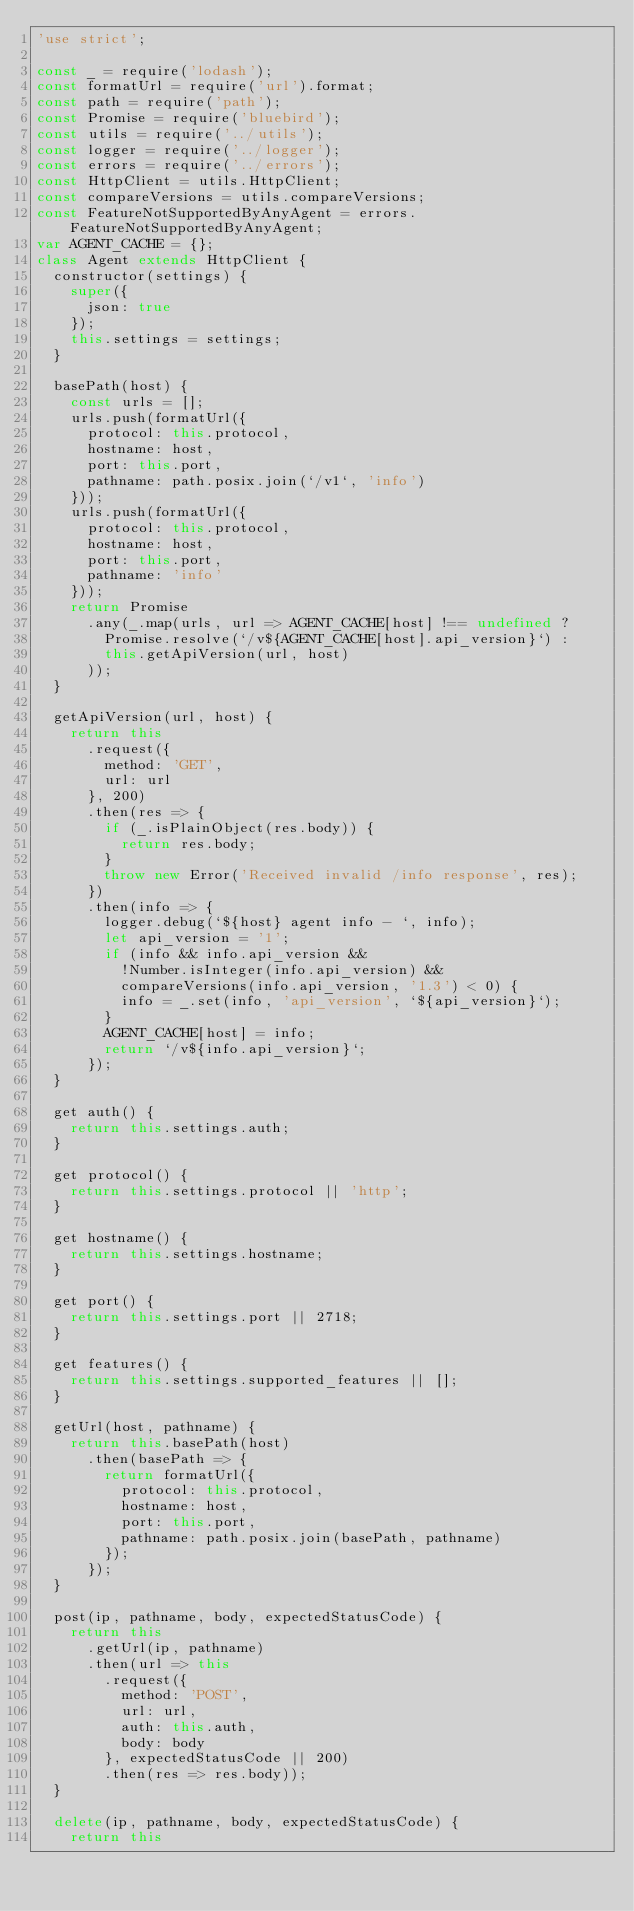Convert code to text. <code><loc_0><loc_0><loc_500><loc_500><_JavaScript_>'use strict';

const _ = require('lodash');
const formatUrl = require('url').format;
const path = require('path');
const Promise = require('bluebird');
const utils = require('../utils');
const logger = require('../logger');
const errors = require('../errors');
const HttpClient = utils.HttpClient;
const compareVersions = utils.compareVersions;
const FeatureNotSupportedByAnyAgent = errors.FeatureNotSupportedByAnyAgent;
var AGENT_CACHE = {};
class Agent extends HttpClient {
  constructor(settings) {
    super({
      json: true
    });
    this.settings = settings;
  }

  basePath(host) {
    const urls = [];
    urls.push(formatUrl({
      protocol: this.protocol,
      hostname: host,
      port: this.port,
      pathname: path.posix.join(`/v1`, 'info')
    }));
    urls.push(formatUrl({
      protocol: this.protocol,
      hostname: host,
      port: this.port,
      pathname: 'info'
    }));
    return Promise
      .any(_.map(urls, url => AGENT_CACHE[host] !== undefined ?
        Promise.resolve(`/v${AGENT_CACHE[host].api_version}`) :
        this.getApiVersion(url, host)
      ));
  }

  getApiVersion(url, host) {
    return this
      .request({
        method: 'GET',
        url: url
      }, 200)
      .then(res => {
        if (_.isPlainObject(res.body)) {
          return res.body;
        }
        throw new Error('Received invalid /info response', res);
      })
      .then(info => {
        logger.debug(`${host} agent info - `, info);
        let api_version = '1';
        if (info && info.api_version &&
          !Number.isInteger(info.api_version) &&
          compareVersions(info.api_version, '1.3') < 0) {
          info = _.set(info, 'api_version', `${api_version}`);
        }
        AGENT_CACHE[host] = info;
        return `/v${info.api_version}`;
      });
  }

  get auth() {
    return this.settings.auth;
  }

  get protocol() {
    return this.settings.protocol || 'http';
  }

  get hostname() {
    return this.settings.hostname;
  }

  get port() {
    return this.settings.port || 2718;
  }

  get features() {
    return this.settings.supported_features || [];
  }

  getUrl(host, pathname) {
    return this.basePath(host)
      .then(basePath => {
        return formatUrl({
          protocol: this.protocol,
          hostname: host,
          port: this.port,
          pathname: path.posix.join(basePath, pathname)
        });
      });
  }

  post(ip, pathname, body, expectedStatusCode) {
    return this
      .getUrl(ip, pathname)
      .then(url => this
        .request({
          method: 'POST',
          url: url,
          auth: this.auth,
          body: body
        }, expectedStatusCode || 200)
        .then(res => res.body));
  }

  delete(ip, pathname, body, expectedStatusCode) {
    return this</code> 